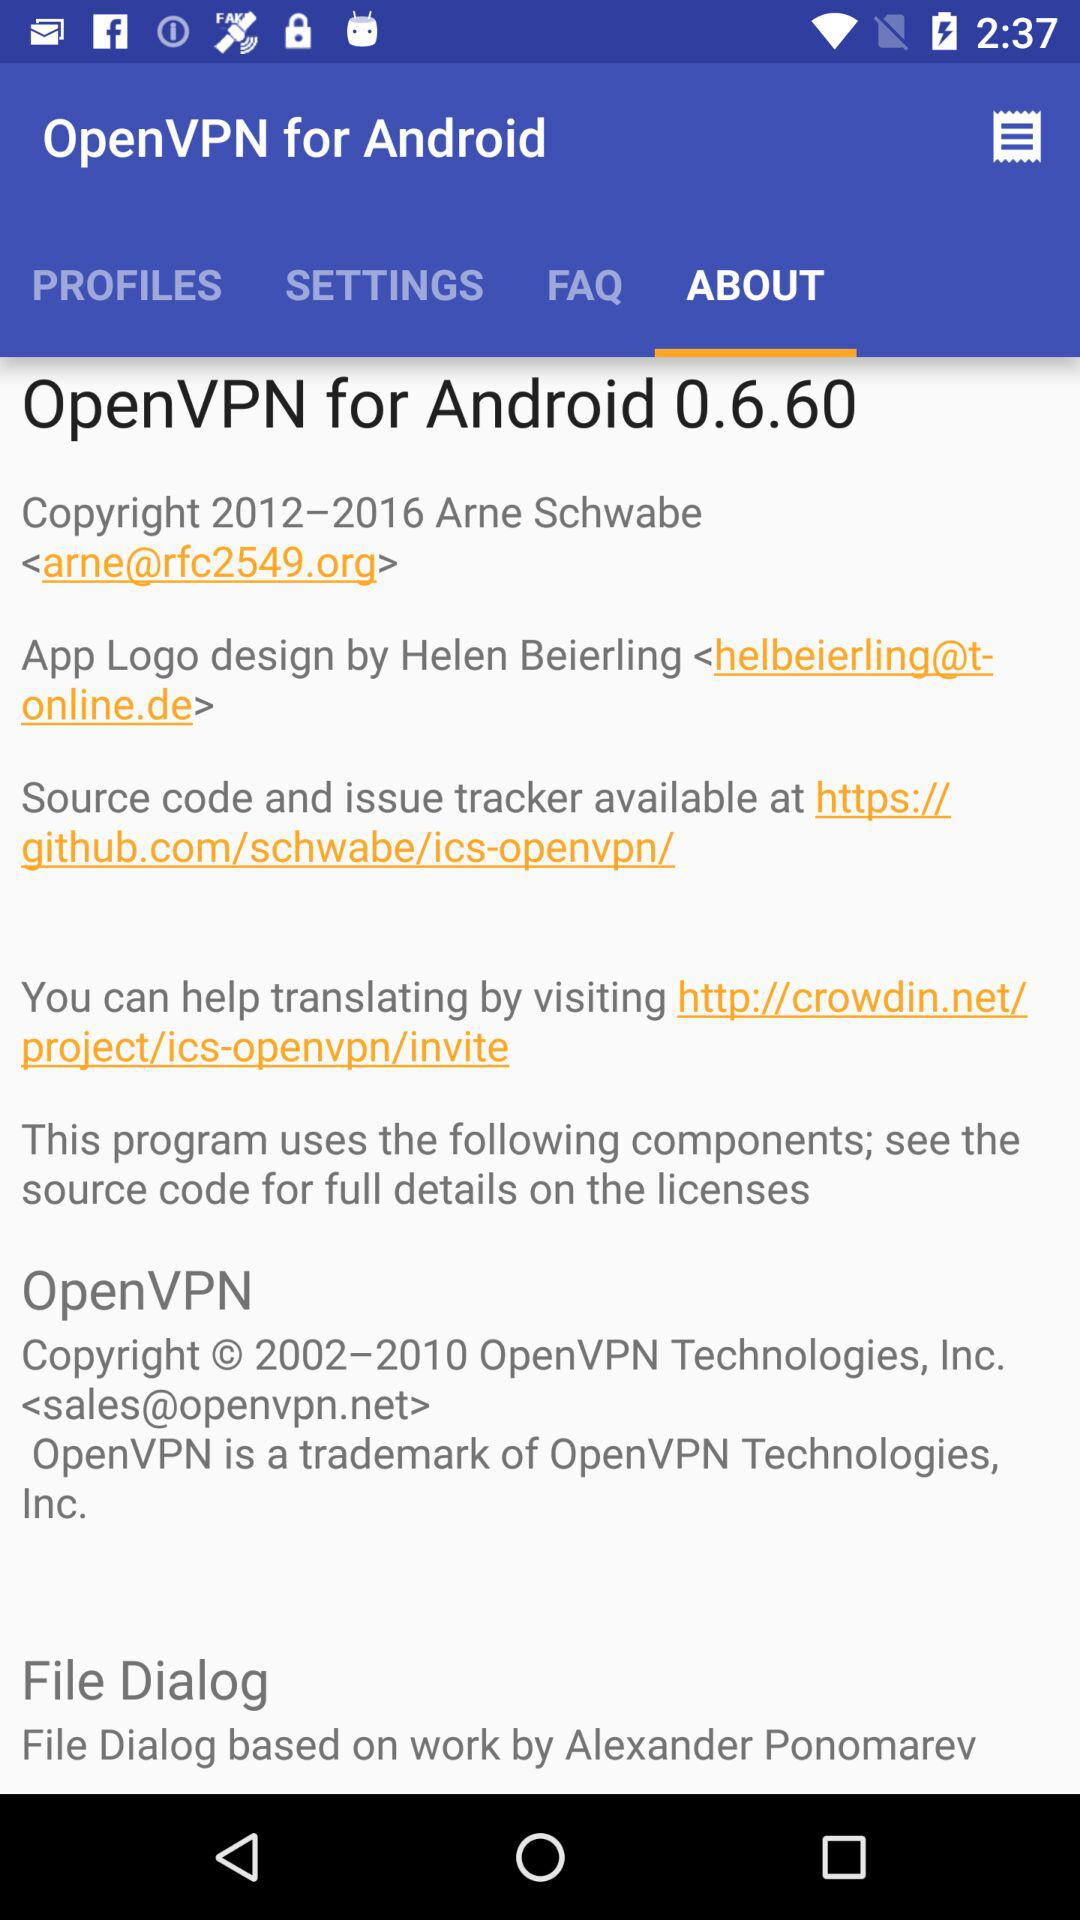What is the application name? The application name is "OpenVPN for Android". 